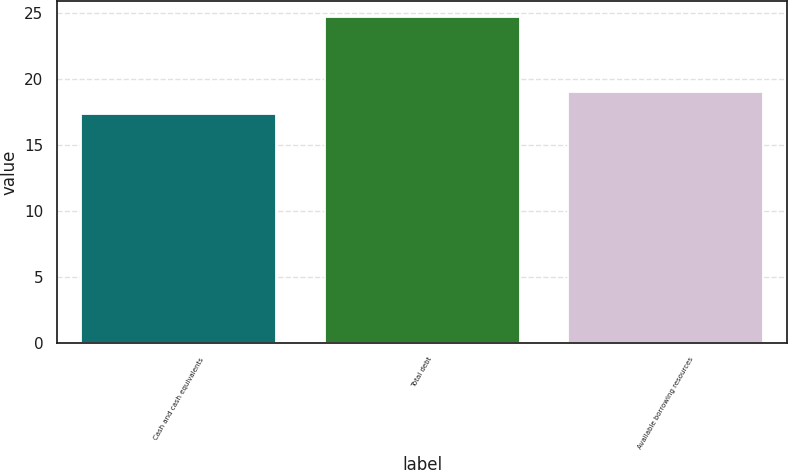Convert chart to OTSL. <chart><loc_0><loc_0><loc_500><loc_500><bar_chart><fcel>Cash and cash equivalents<fcel>Total debt<fcel>Available borrowing resources<nl><fcel>17.4<fcel>24.7<fcel>19<nl></chart> 